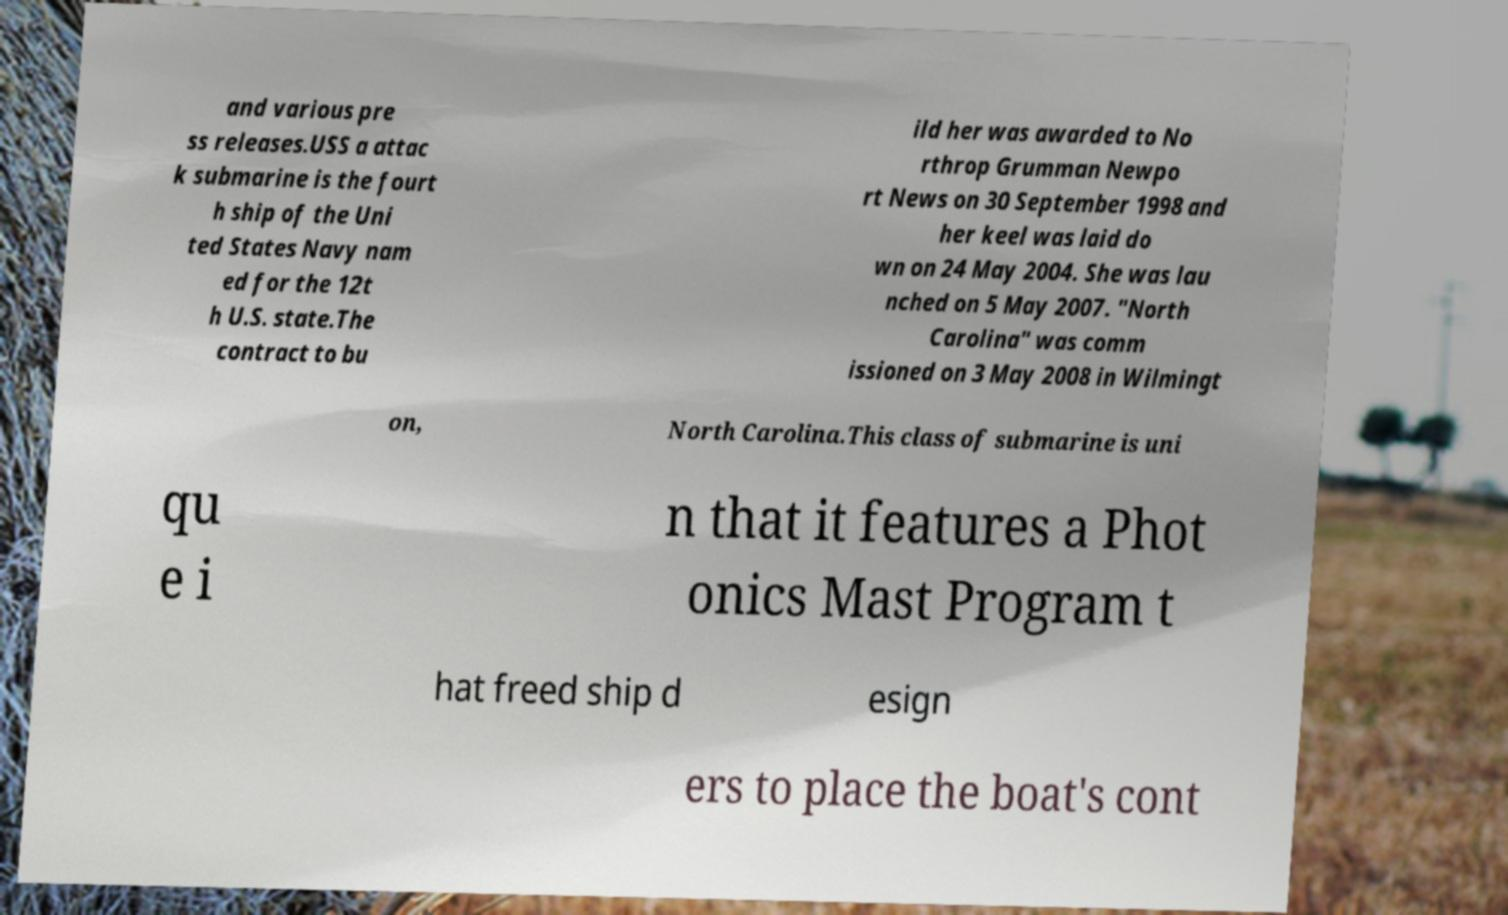Could you extract and type out the text from this image? and various pre ss releases.USS a attac k submarine is the fourt h ship of the Uni ted States Navy nam ed for the 12t h U.S. state.The contract to bu ild her was awarded to No rthrop Grumman Newpo rt News on 30 September 1998 and her keel was laid do wn on 24 May 2004. She was lau nched on 5 May 2007. "North Carolina" was comm issioned on 3 May 2008 in Wilmingt on, North Carolina.This class of submarine is uni qu e i n that it features a Phot onics Mast Program t hat freed ship d esign ers to place the boat's cont 